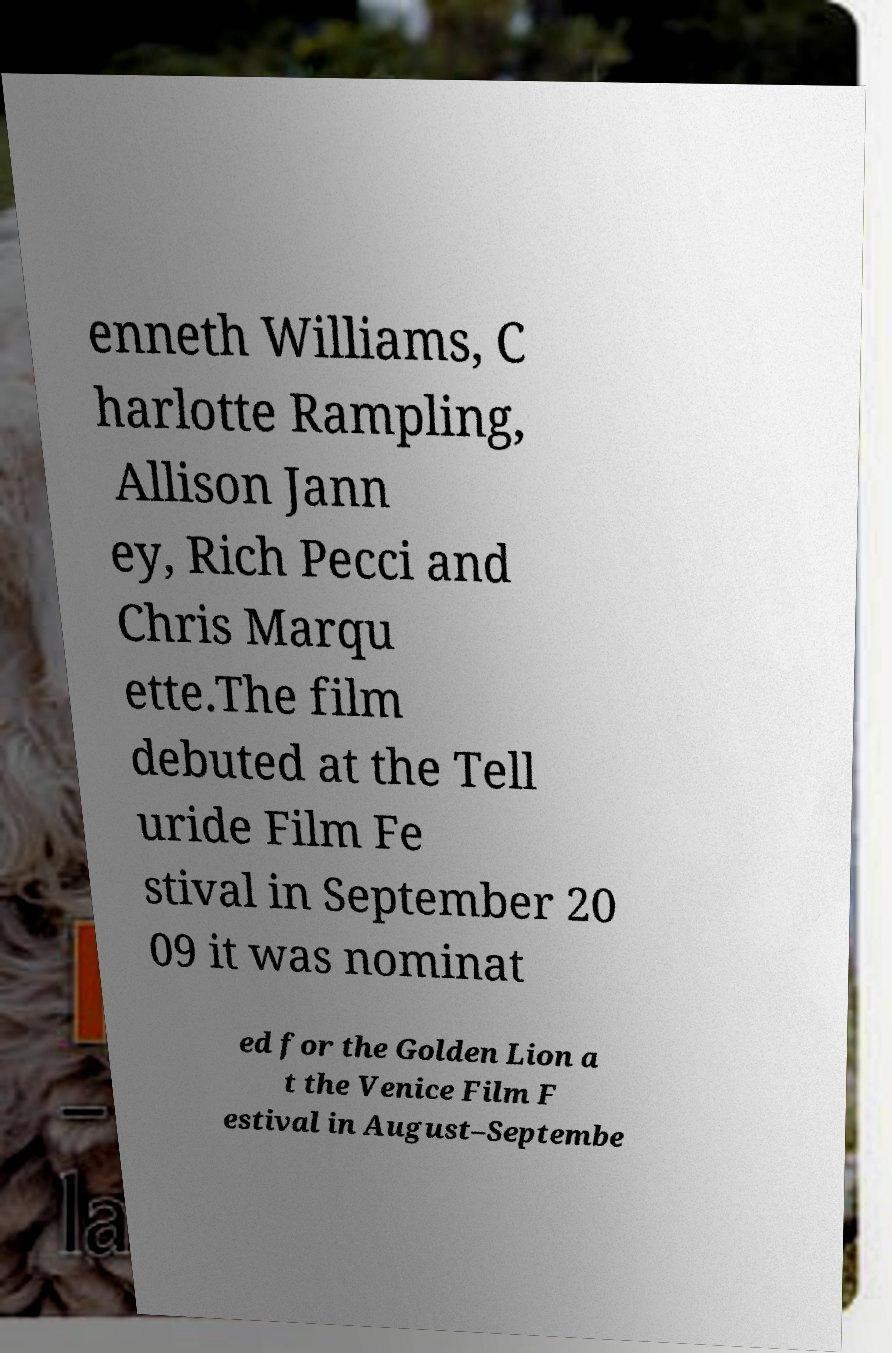There's text embedded in this image that I need extracted. Can you transcribe it verbatim? enneth Williams, C harlotte Rampling, Allison Jann ey, Rich Pecci and Chris Marqu ette.The film debuted at the Tell uride Film Fe stival in September 20 09 it was nominat ed for the Golden Lion a t the Venice Film F estival in August–Septembe 